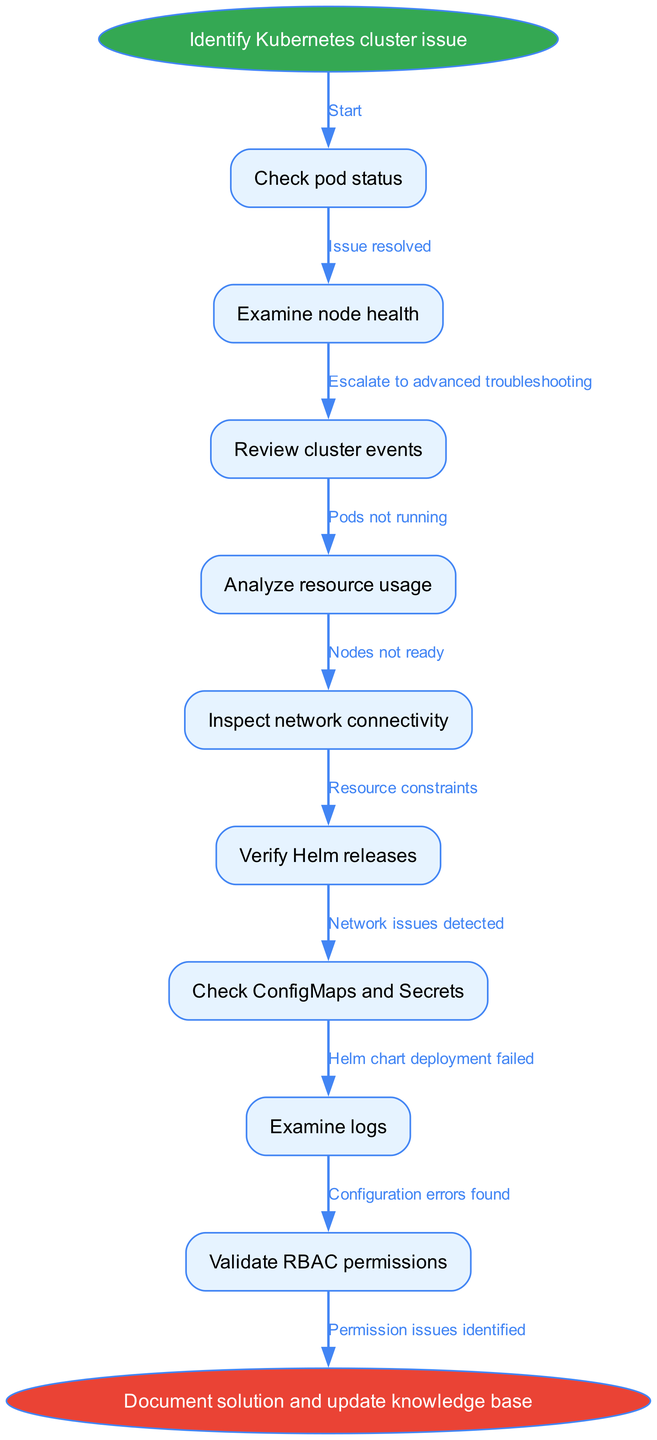What is the starting point in the diagram? The starting point is labeled "Identify Kubernetes cluster issue" and is represented as the first node in the flow, branching out to further troubleshooting steps.
Answer: Identify Kubernetes cluster issue How many nodes are there in total? The diagram includes 9 nodes: 1 start node, 8 troubleshooting steps, and 1 end node, giving a total of 10 nodes.
Answer: 10 nodes What is the relationship between "Check pod status" and "Examine node health"? "Check pod status" leads to "Examine node health" as the next step in troubleshooting, indicating the flow of actions to identify issues.
Answer: Leads to Which node follows "Review cluster events"? The node that follows "Review cluster events" is "Analyze resource usage," indicating the next area of focus in troubleshooting.
Answer: Analyze resource usage If "Inspect network connectivity" detects issues, what is the next step to take? If network issues are detected at the "Inspect network connectivity" step, you should escalate to advanced troubleshooting as indicated by the flow.
Answer: Escalate to advanced troubleshooting What happens if configuration errors are found? If configuration errors are identified during the "Check ConfigMaps and Secrets" step, the flow leads to escalating the issue as well.
Answer: Escalate to advanced troubleshooting Which nodes are categorized as "Issue path nodes" that can lead to a resolution? The nodes "Check pod status," "Examine node health," "Review cluster events," and "Analyze resource usage" lead to issue resolution evaluations in the flow.
Answer: Check pod status, Examine node health, Review cluster events, Analyze resource usage What is the end point of the troubleshooting flow? The end point of the troubleshooting flow is labeled "Document solution and update knowledge base," which summarizes the completion of the process.
Answer: Document solution and update knowledge base 